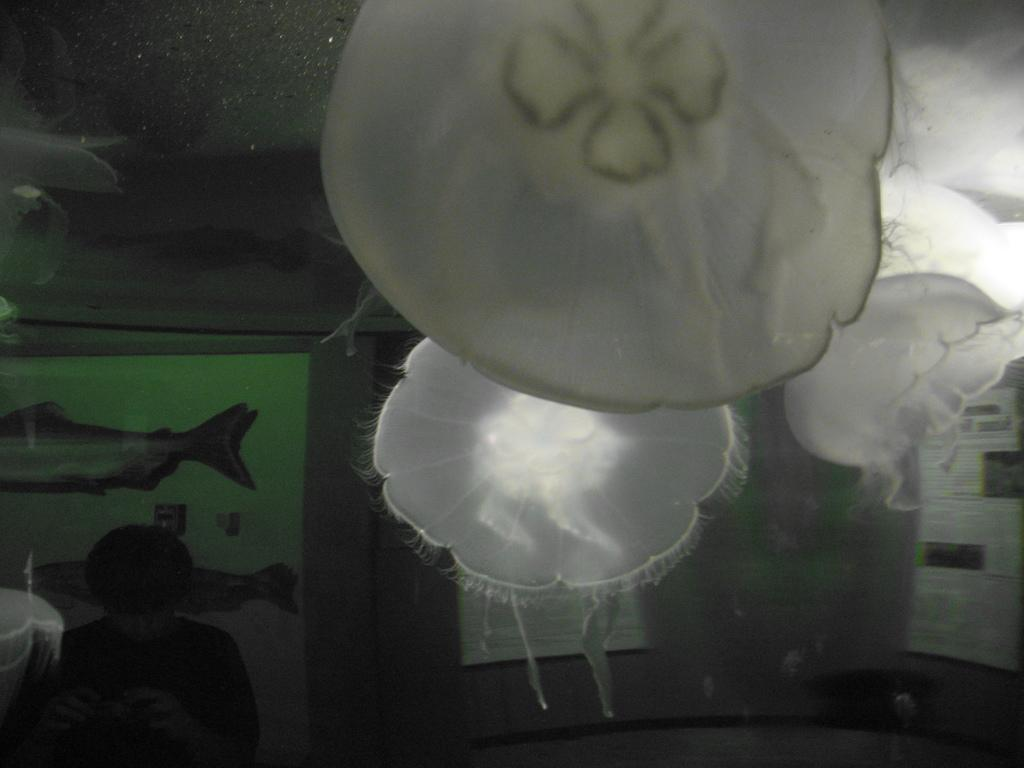What type of sea creatures are in the image? There are jelly fishes in the image. Can you describe the person in the image? There is a person in the image. What else is present in the image besides the jelly fishes and the person? There are papers in the image. How does the person transport the jelly fishes in the image? There is no indication in the image that the person is transporting the jelly fishes. 